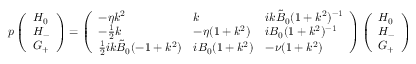Convert formula to latex. <formula><loc_0><loc_0><loc_500><loc_500>p \left ( \begin{array} { l } { H _ { 0 } } \\ { H _ { - } } \\ { G _ { + } } \end{array} \right ) = \left ( \begin{array} { l l l } { - \eta k ^ { 2 } } & { k } & { i k \tilde { B } _ { 0 } ( 1 + k ^ { 2 } ) ^ { - 1 } } \\ { - \frac { 1 } { 2 } k } & { - \eta ( 1 + k ^ { 2 } ) } & { i B _ { 0 } ( 1 + k ^ { 2 } ) ^ { - 1 } } \\ { \frac { 1 } { 2 } i k \tilde { B } _ { 0 } ( - 1 + k ^ { 2 } ) } & { i B _ { 0 } ( 1 + k ^ { 2 } ) } & { - \nu ( 1 + k ^ { 2 } ) } \end{array} \right ) \left ( \begin{array} { l } { H _ { 0 } } \\ { H _ { - } } \\ { G _ { + } } \end{array} \right )</formula> 